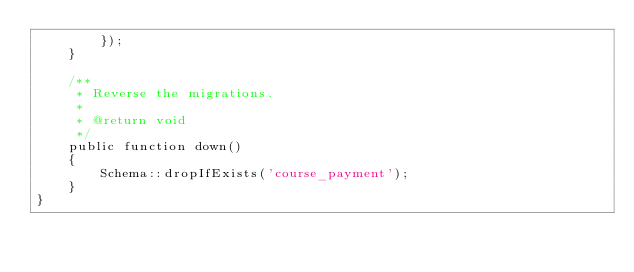<code> <loc_0><loc_0><loc_500><loc_500><_PHP_>        });
    }

    /**
     * Reverse the migrations.
     *
     * @return void
     */
    public function down()
    {
        Schema::dropIfExists('course_payment');
    }
}
</code> 